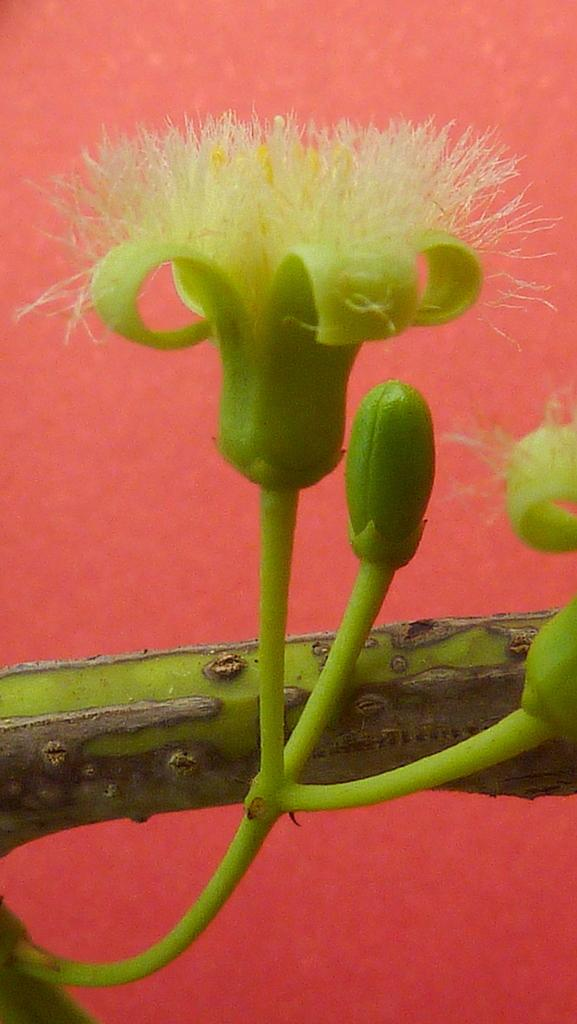What is the main subject of the picture? There is a flowering plant in the picture. Can you describe the background of the picture? The background of the picture is colored. Based on the presence of a flowering plant, when might the picture have been taken? The picture might have been taken during the day, as flowering plants are typically photographed during daylight. What type of drink is being offered to the flowering plant in the image? There is no drink present in the image, as it features a flowering plant and a colored background. 